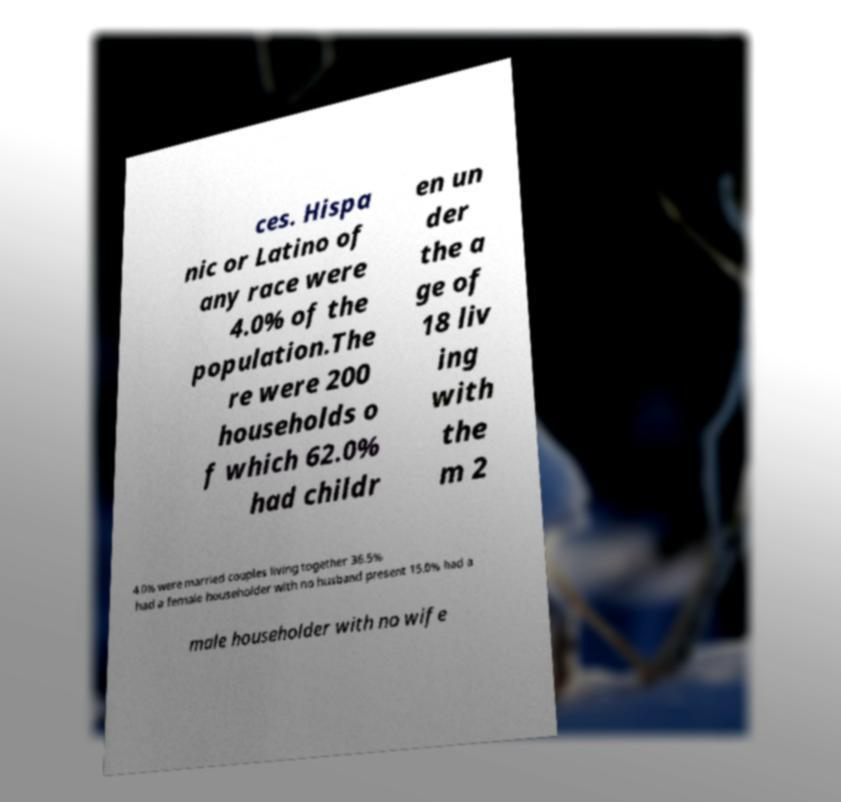For documentation purposes, I need the text within this image transcribed. Could you provide that? ces. Hispa nic or Latino of any race were 4.0% of the population.The re were 200 households o f which 62.0% had childr en un der the a ge of 18 liv ing with the m 2 4.0% were married couples living together 36.5% had a female householder with no husband present 15.0% had a male householder with no wife 